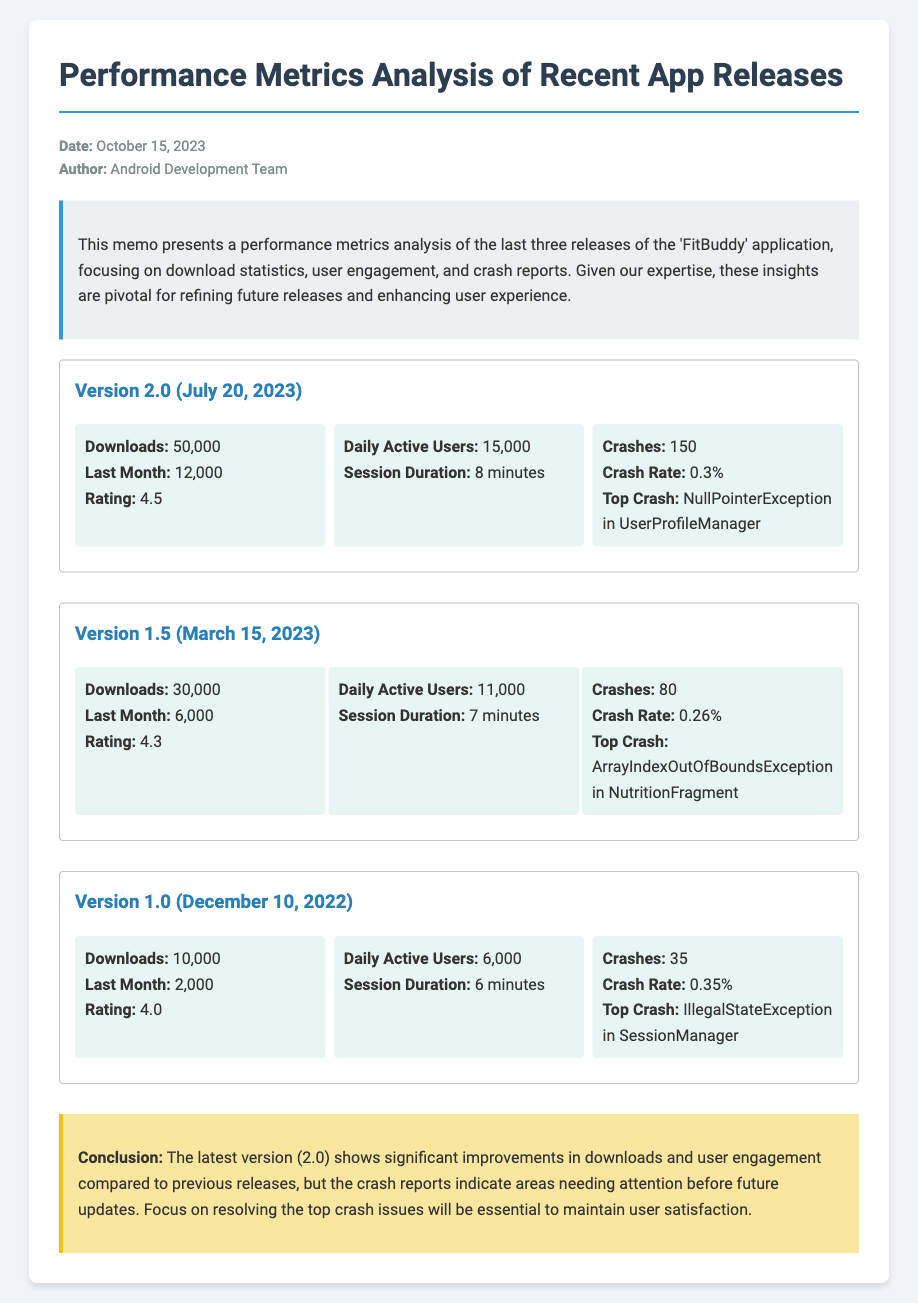What is the date of the memo? The date of the memo is stated in the meta section of the document.
Answer: October 15, 2023 How many downloads did version 2.0 have? The number of downloads for version 2.0 is mentioned in the release section.
Answer: 50,000 What is the crash rate for version 1.5? The crash rate for version 1.5 can be found in the stats of that release.
Answer: 0.26% Which version has the highest daily active users? The daily active users for each version allows for a comparison to find the highest figure.
Answer: Version 2.0 What was the top crash for version 1.0? The top crash for version 1.0 is listed in the crash report section of that release.
Answer: IllegalStateException in SessionManager Which version had the lowest overall rating? The ratings for each version allow for determining which one is the lowest.
Answer: Version 1.0 What is the session duration for version 2.0? The session duration is detailed in the stats for version 2.0.
Answer: 8 minutes What does the conclusion state about version 2.0? The conclusion provides insights into what version 2.0 requires, based on metrics.
Answer: Significant improvements in downloads and user engagement 